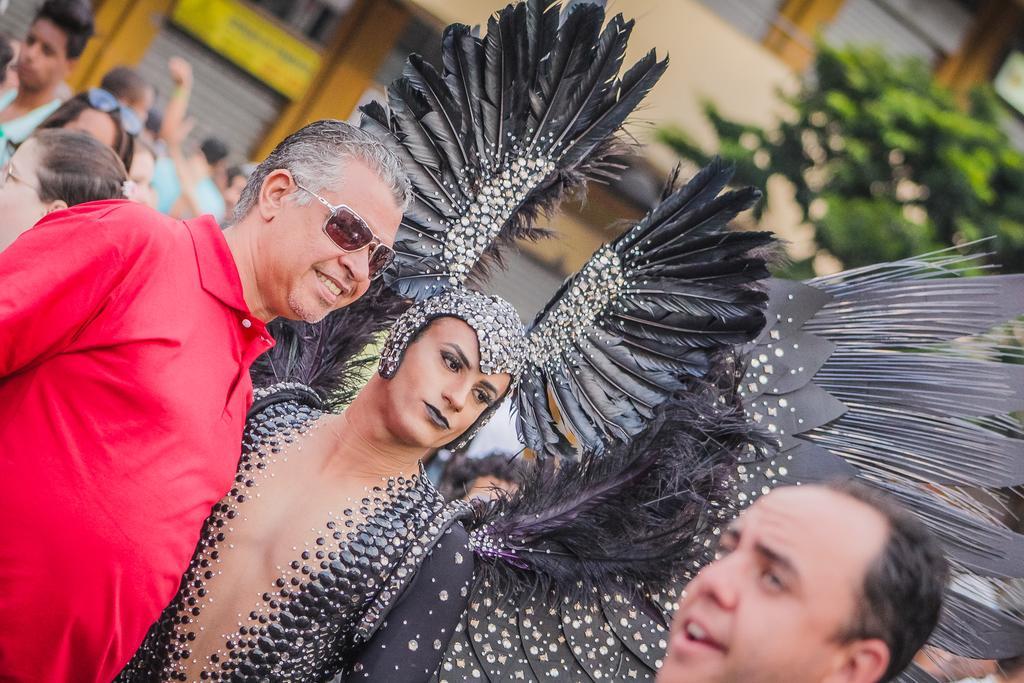Could you give a brief overview of what you see in this image? In this image I see 2 men and a woman in front and I see that this woman is wearing black and silver color costume and I see that this man is smiling. In the background I see few more people and I see the building and the green color thing over here. 